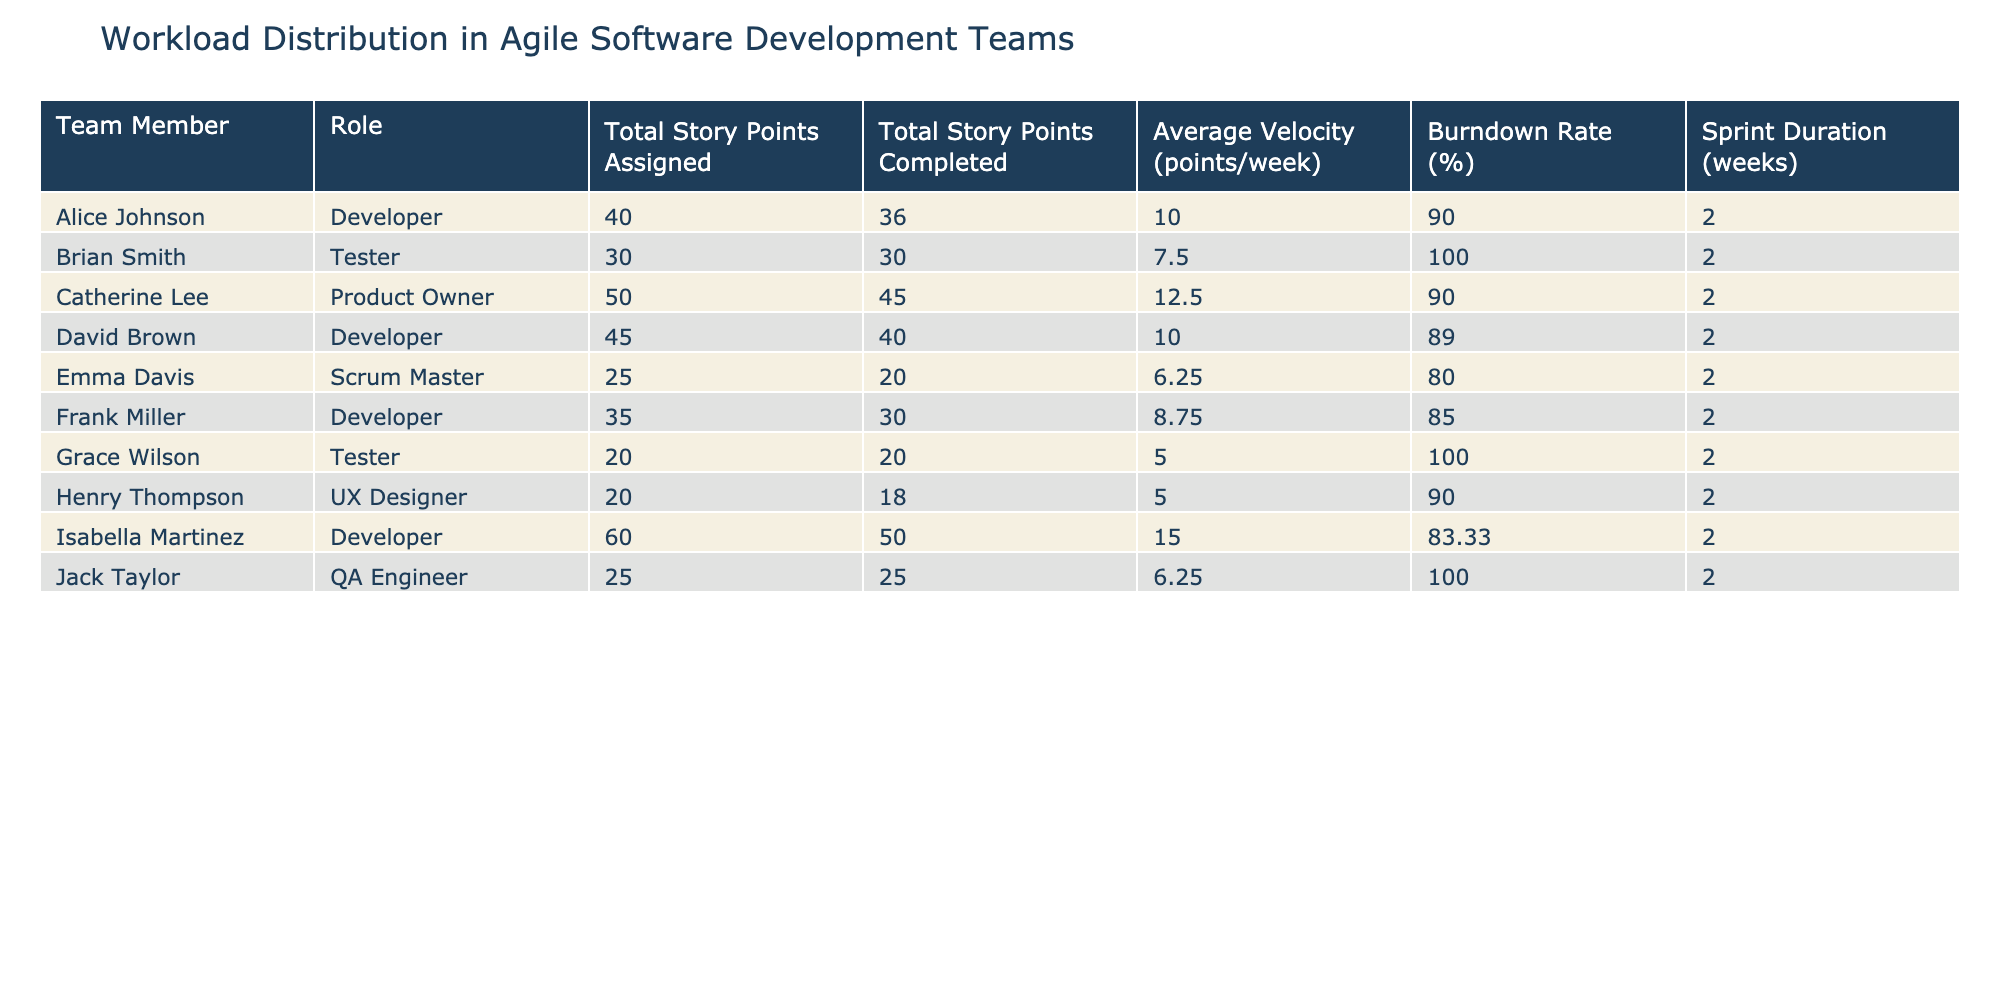What is the total story points assigned to Alice Johnson? According to the table, Alice Johnson has a total of 40 story points assigned. This value can be found directly in the "Total Story Points Assigned" column corresponding to her name.
Answer: 40 Which team member completed the highest number of story points? By reviewing the "Total Story Points Completed" column, we see that Isabella Martinez completed 50 story points, which is the highest value in that column.
Answer: Isabella Martinez What is the average velocity of the team members? To calculate the average velocity, we sum the "Average Velocity (points/week)" values for all members (10 + 7.5 + 12.5 + 10 + 6.25 + 8.75 + 5 + 5 + 15 + 6.25 = 81.25) and divide by the number of members (10). Therefore, the average is 81.25 / 10 = 8.125 points/week.
Answer: 8.125 Is the burndown rate for David Brown above 85%? David Brown's burndown rate is listed as 89%, which is indeed above 85%. This can be confirmed by checking the "Burndown Rate (%)" column for his row.
Answer: Yes Who has the lowest average velocity? Examining the "Average Velocity (points/week)" column, we see that Grace Wilson has the lowest average velocity of 5 points/week. This is the smallest number in that column.
Answer: Grace Wilson What is the difference between the total story points assigned and completed for Frank Miller? Frank Miller has 35 story points assigned and 30 completed. The difference is calculated by subtracting the completed from the assigned (35 - 30 = 5). Thus, he has 5 story points that remain incomplete.
Answer: 5 Did all the testers in the table complete their assigned story points? Reviewing both testers, Brian Smith and Grace Wilson, we see they both completed all their assigned story points (30 and 20 respectively). Therefore, it can be concluded that yes, all testers completed their assigned points.
Answer: Yes What is the total sprint duration of all team members combined? The sprint duration is given as 2 weeks for each team member in the table. With 10 members, the total sprint duration is calculated as 2 weeks * 10 members = 20 weeks.
Answer: 20 weeks Which member has the highest burndown rate, and what is its value? By looking at the "Burndown Rate (%)" column, we can see that Grace Wilson, Brian Smith, and Jack Taylor have a burndown rate of 100%, which is the highest among the team members.
Answer: Grace Wilson, 100% 